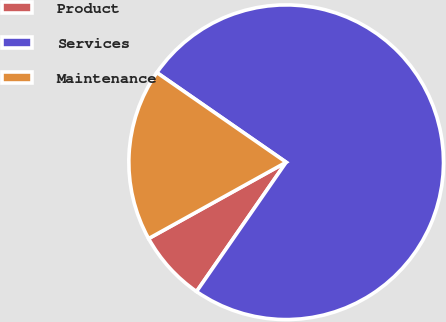<chart> <loc_0><loc_0><loc_500><loc_500><pie_chart><fcel>Product<fcel>Services<fcel>Maintenance<nl><fcel>7.29%<fcel>75.0%<fcel>17.71%<nl></chart> 